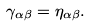Convert formula to latex. <formula><loc_0><loc_0><loc_500><loc_500>\gamma _ { \alpha \beta } & = \eta _ { \alpha \beta } .</formula> 